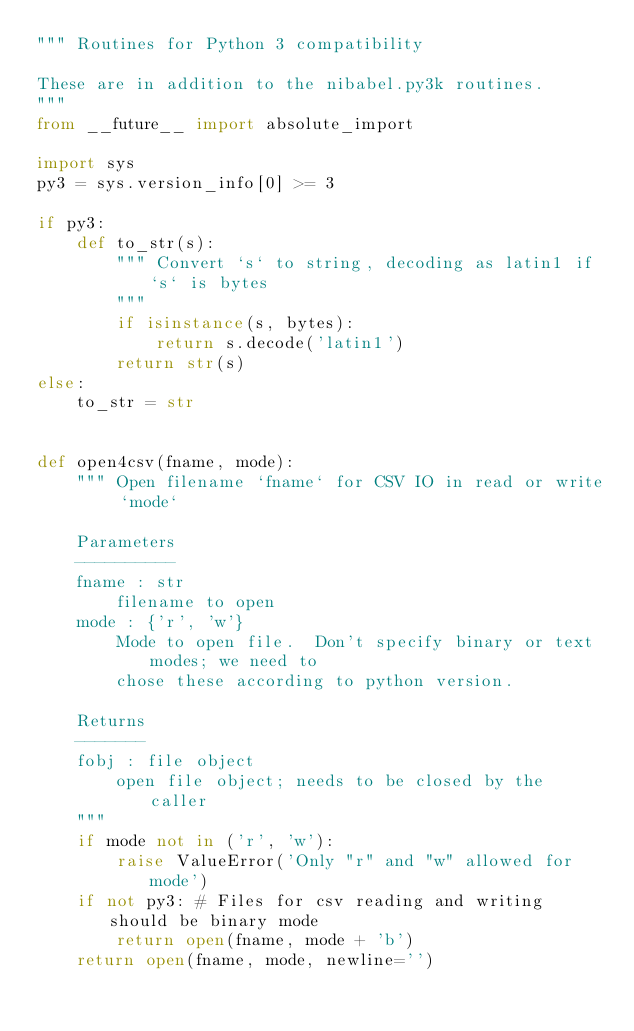<code> <loc_0><loc_0><loc_500><loc_500><_Python_>""" Routines for Python 3 compatibility

These are in addition to the nibabel.py3k routines.
"""
from __future__ import absolute_import

import sys
py3 = sys.version_info[0] >= 3

if py3:
    def to_str(s):
        """ Convert `s` to string, decoding as latin1 if `s` is bytes
        """
        if isinstance(s, bytes):
            return s.decode('latin1')
        return str(s)
else:
    to_str = str


def open4csv(fname, mode):
    """ Open filename `fname` for CSV IO in read or write `mode`

    Parameters
    ----------
    fname : str
        filename to open
    mode : {'r', 'w'}
        Mode to open file.  Don't specify binary or text modes; we need to
        chose these according to python version.

    Returns
    -------
    fobj : file object
        open file object; needs to be closed by the caller
    """
    if mode not in ('r', 'w'):
        raise ValueError('Only "r" and "w" allowed for mode')
    if not py3: # Files for csv reading and writing should be binary mode
        return open(fname, mode + 'b')
    return open(fname, mode, newline='')
</code> 